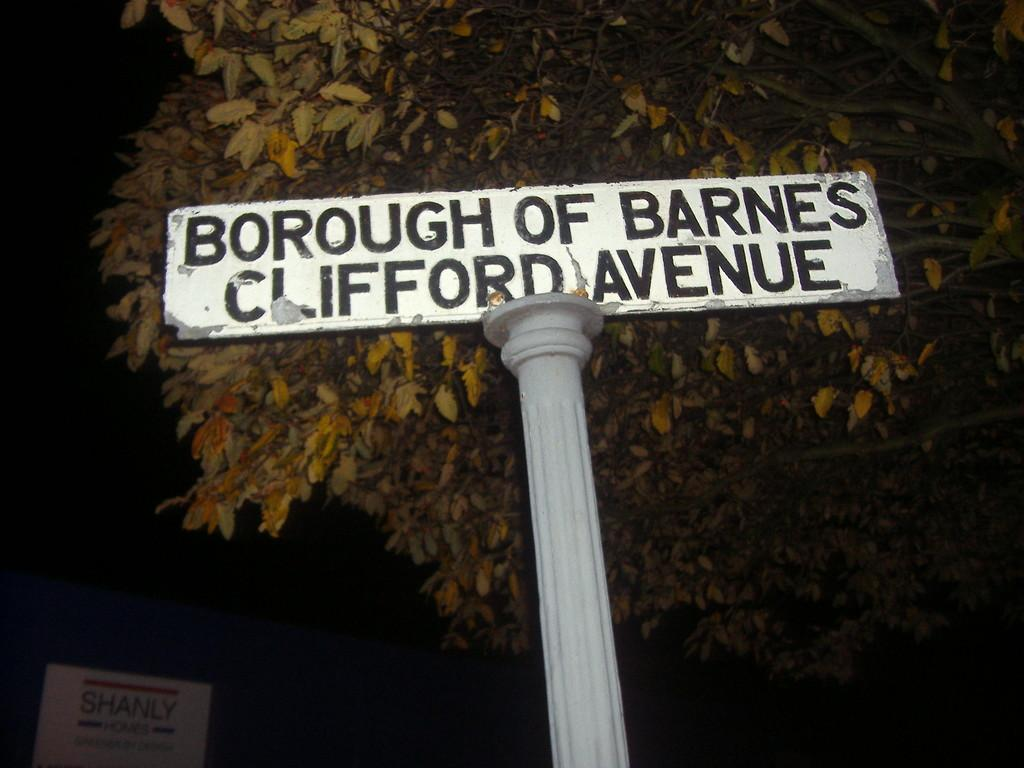What is on the pole that is visible in the image? There is a plate with some text on it in the image. What type of natural element can be seen in the image? There is a tree in the image. What is located in the bottom left corner of the image? There is an object in the bottom left corner of the image. How would you describe the overall lighting in the image? The background of the image is dark. What type of rule is being enforced by the tree in the image? There is no rule being enforced by the tree in the image; it is simply a natural element in the scene. What kind of loaf is being served on the plate in the image? There is no loaf present on the plate in the image; it has some text instead. 